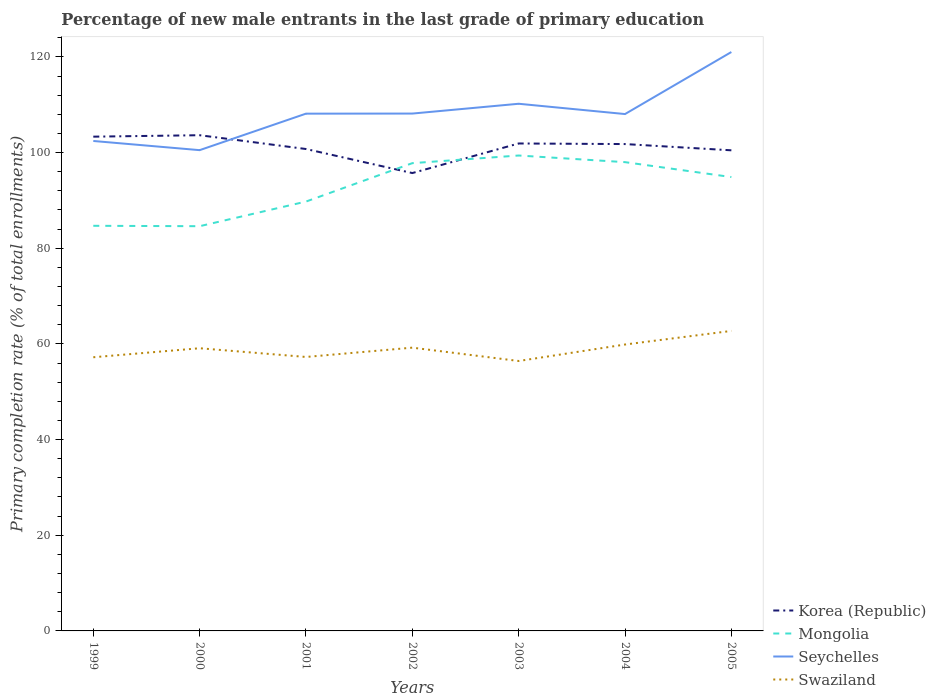How many different coloured lines are there?
Make the answer very short. 4. Across all years, what is the maximum percentage of new male entrants in Mongolia?
Your answer should be very brief. 84.61. What is the total percentage of new male entrants in Seychelles in the graph?
Give a very brief answer. -7.55. What is the difference between the highest and the second highest percentage of new male entrants in Seychelles?
Offer a very short reply. 20.51. How many years are there in the graph?
Ensure brevity in your answer.  7. What is the difference between two consecutive major ticks on the Y-axis?
Provide a succinct answer. 20. Where does the legend appear in the graph?
Keep it short and to the point. Bottom right. How many legend labels are there?
Make the answer very short. 4. What is the title of the graph?
Ensure brevity in your answer.  Percentage of new male entrants in the last grade of primary education. What is the label or title of the Y-axis?
Make the answer very short. Primary completion rate (% of total enrollments). What is the Primary completion rate (% of total enrollments) of Korea (Republic) in 1999?
Make the answer very short. 103.32. What is the Primary completion rate (% of total enrollments) of Mongolia in 1999?
Offer a very short reply. 84.69. What is the Primary completion rate (% of total enrollments) in Seychelles in 1999?
Offer a very short reply. 102.42. What is the Primary completion rate (% of total enrollments) in Swaziland in 1999?
Give a very brief answer. 57.21. What is the Primary completion rate (% of total enrollments) of Korea (Republic) in 2000?
Your answer should be compact. 103.63. What is the Primary completion rate (% of total enrollments) of Mongolia in 2000?
Ensure brevity in your answer.  84.61. What is the Primary completion rate (% of total enrollments) of Seychelles in 2000?
Give a very brief answer. 100.5. What is the Primary completion rate (% of total enrollments) in Swaziland in 2000?
Offer a very short reply. 59.09. What is the Primary completion rate (% of total enrollments) of Korea (Republic) in 2001?
Provide a short and direct response. 100.74. What is the Primary completion rate (% of total enrollments) of Mongolia in 2001?
Keep it short and to the point. 89.75. What is the Primary completion rate (% of total enrollments) of Seychelles in 2001?
Your response must be concise. 108.13. What is the Primary completion rate (% of total enrollments) in Swaziland in 2001?
Offer a terse response. 57.27. What is the Primary completion rate (% of total enrollments) in Korea (Republic) in 2002?
Provide a succinct answer. 95.71. What is the Primary completion rate (% of total enrollments) of Mongolia in 2002?
Keep it short and to the point. 97.78. What is the Primary completion rate (% of total enrollments) in Seychelles in 2002?
Your answer should be compact. 108.15. What is the Primary completion rate (% of total enrollments) of Swaziland in 2002?
Make the answer very short. 59.22. What is the Primary completion rate (% of total enrollments) in Korea (Republic) in 2003?
Give a very brief answer. 101.9. What is the Primary completion rate (% of total enrollments) in Mongolia in 2003?
Your response must be concise. 99.38. What is the Primary completion rate (% of total enrollments) of Seychelles in 2003?
Your response must be concise. 110.2. What is the Primary completion rate (% of total enrollments) in Swaziland in 2003?
Ensure brevity in your answer.  56.43. What is the Primary completion rate (% of total enrollments) in Korea (Republic) in 2004?
Make the answer very short. 101.77. What is the Primary completion rate (% of total enrollments) of Mongolia in 2004?
Provide a short and direct response. 98. What is the Primary completion rate (% of total enrollments) in Seychelles in 2004?
Provide a short and direct response. 108.05. What is the Primary completion rate (% of total enrollments) of Swaziland in 2004?
Ensure brevity in your answer.  59.87. What is the Primary completion rate (% of total enrollments) in Korea (Republic) in 2005?
Your response must be concise. 100.47. What is the Primary completion rate (% of total enrollments) in Mongolia in 2005?
Your response must be concise. 94.88. What is the Primary completion rate (% of total enrollments) in Seychelles in 2005?
Your answer should be compact. 121.02. What is the Primary completion rate (% of total enrollments) in Swaziland in 2005?
Your response must be concise. 62.72. Across all years, what is the maximum Primary completion rate (% of total enrollments) of Korea (Republic)?
Give a very brief answer. 103.63. Across all years, what is the maximum Primary completion rate (% of total enrollments) of Mongolia?
Your answer should be very brief. 99.38. Across all years, what is the maximum Primary completion rate (% of total enrollments) in Seychelles?
Give a very brief answer. 121.02. Across all years, what is the maximum Primary completion rate (% of total enrollments) in Swaziland?
Give a very brief answer. 62.72. Across all years, what is the minimum Primary completion rate (% of total enrollments) in Korea (Republic)?
Keep it short and to the point. 95.71. Across all years, what is the minimum Primary completion rate (% of total enrollments) in Mongolia?
Offer a terse response. 84.61. Across all years, what is the minimum Primary completion rate (% of total enrollments) in Seychelles?
Your answer should be very brief. 100.5. Across all years, what is the minimum Primary completion rate (% of total enrollments) in Swaziland?
Your answer should be compact. 56.43. What is the total Primary completion rate (% of total enrollments) of Korea (Republic) in the graph?
Your answer should be compact. 707.54. What is the total Primary completion rate (% of total enrollments) of Mongolia in the graph?
Your response must be concise. 649.09. What is the total Primary completion rate (% of total enrollments) of Seychelles in the graph?
Provide a succinct answer. 758.47. What is the total Primary completion rate (% of total enrollments) in Swaziland in the graph?
Provide a succinct answer. 411.8. What is the difference between the Primary completion rate (% of total enrollments) in Korea (Republic) in 1999 and that in 2000?
Offer a terse response. -0.3. What is the difference between the Primary completion rate (% of total enrollments) in Mongolia in 1999 and that in 2000?
Offer a terse response. 0.08. What is the difference between the Primary completion rate (% of total enrollments) of Seychelles in 1999 and that in 2000?
Your response must be concise. 1.92. What is the difference between the Primary completion rate (% of total enrollments) in Swaziland in 1999 and that in 2000?
Provide a short and direct response. -1.88. What is the difference between the Primary completion rate (% of total enrollments) of Korea (Republic) in 1999 and that in 2001?
Offer a terse response. 2.58. What is the difference between the Primary completion rate (% of total enrollments) of Mongolia in 1999 and that in 2001?
Your response must be concise. -5.07. What is the difference between the Primary completion rate (% of total enrollments) in Seychelles in 1999 and that in 2001?
Give a very brief answer. -5.71. What is the difference between the Primary completion rate (% of total enrollments) of Swaziland in 1999 and that in 2001?
Ensure brevity in your answer.  -0.06. What is the difference between the Primary completion rate (% of total enrollments) in Korea (Republic) in 1999 and that in 2002?
Offer a very short reply. 7.61. What is the difference between the Primary completion rate (% of total enrollments) in Mongolia in 1999 and that in 2002?
Offer a terse response. -13.1. What is the difference between the Primary completion rate (% of total enrollments) of Seychelles in 1999 and that in 2002?
Your answer should be very brief. -5.73. What is the difference between the Primary completion rate (% of total enrollments) of Swaziland in 1999 and that in 2002?
Ensure brevity in your answer.  -2.01. What is the difference between the Primary completion rate (% of total enrollments) in Korea (Republic) in 1999 and that in 2003?
Offer a very short reply. 1.42. What is the difference between the Primary completion rate (% of total enrollments) of Mongolia in 1999 and that in 2003?
Give a very brief answer. -14.69. What is the difference between the Primary completion rate (% of total enrollments) in Seychelles in 1999 and that in 2003?
Make the answer very short. -7.78. What is the difference between the Primary completion rate (% of total enrollments) in Swaziland in 1999 and that in 2003?
Offer a very short reply. 0.78. What is the difference between the Primary completion rate (% of total enrollments) in Korea (Republic) in 1999 and that in 2004?
Make the answer very short. 1.55. What is the difference between the Primary completion rate (% of total enrollments) in Mongolia in 1999 and that in 2004?
Keep it short and to the point. -13.31. What is the difference between the Primary completion rate (% of total enrollments) of Seychelles in 1999 and that in 2004?
Your answer should be compact. -5.63. What is the difference between the Primary completion rate (% of total enrollments) in Swaziland in 1999 and that in 2004?
Give a very brief answer. -2.66. What is the difference between the Primary completion rate (% of total enrollments) in Korea (Republic) in 1999 and that in 2005?
Your answer should be compact. 2.86. What is the difference between the Primary completion rate (% of total enrollments) of Mongolia in 1999 and that in 2005?
Provide a succinct answer. -10.19. What is the difference between the Primary completion rate (% of total enrollments) of Seychelles in 1999 and that in 2005?
Provide a succinct answer. -18.6. What is the difference between the Primary completion rate (% of total enrollments) in Swaziland in 1999 and that in 2005?
Give a very brief answer. -5.5. What is the difference between the Primary completion rate (% of total enrollments) of Korea (Republic) in 2000 and that in 2001?
Offer a very short reply. 2.89. What is the difference between the Primary completion rate (% of total enrollments) of Mongolia in 2000 and that in 2001?
Ensure brevity in your answer.  -5.15. What is the difference between the Primary completion rate (% of total enrollments) of Seychelles in 2000 and that in 2001?
Provide a short and direct response. -7.63. What is the difference between the Primary completion rate (% of total enrollments) in Swaziland in 2000 and that in 2001?
Your answer should be compact. 1.82. What is the difference between the Primary completion rate (% of total enrollments) of Korea (Republic) in 2000 and that in 2002?
Keep it short and to the point. 7.91. What is the difference between the Primary completion rate (% of total enrollments) in Mongolia in 2000 and that in 2002?
Offer a very short reply. -13.18. What is the difference between the Primary completion rate (% of total enrollments) in Seychelles in 2000 and that in 2002?
Provide a succinct answer. -7.65. What is the difference between the Primary completion rate (% of total enrollments) in Swaziland in 2000 and that in 2002?
Your answer should be very brief. -0.12. What is the difference between the Primary completion rate (% of total enrollments) of Korea (Republic) in 2000 and that in 2003?
Provide a short and direct response. 1.73. What is the difference between the Primary completion rate (% of total enrollments) of Mongolia in 2000 and that in 2003?
Ensure brevity in your answer.  -14.78. What is the difference between the Primary completion rate (% of total enrollments) of Seychelles in 2000 and that in 2003?
Provide a short and direct response. -9.7. What is the difference between the Primary completion rate (% of total enrollments) in Swaziland in 2000 and that in 2003?
Your response must be concise. 2.67. What is the difference between the Primary completion rate (% of total enrollments) in Korea (Republic) in 2000 and that in 2004?
Ensure brevity in your answer.  1.85. What is the difference between the Primary completion rate (% of total enrollments) of Mongolia in 2000 and that in 2004?
Provide a short and direct response. -13.39. What is the difference between the Primary completion rate (% of total enrollments) of Seychelles in 2000 and that in 2004?
Make the answer very short. -7.55. What is the difference between the Primary completion rate (% of total enrollments) in Swaziland in 2000 and that in 2004?
Provide a short and direct response. -0.78. What is the difference between the Primary completion rate (% of total enrollments) in Korea (Republic) in 2000 and that in 2005?
Give a very brief answer. 3.16. What is the difference between the Primary completion rate (% of total enrollments) in Mongolia in 2000 and that in 2005?
Offer a very short reply. -10.27. What is the difference between the Primary completion rate (% of total enrollments) of Seychelles in 2000 and that in 2005?
Your answer should be compact. -20.51. What is the difference between the Primary completion rate (% of total enrollments) in Swaziland in 2000 and that in 2005?
Give a very brief answer. -3.62. What is the difference between the Primary completion rate (% of total enrollments) in Korea (Republic) in 2001 and that in 2002?
Provide a succinct answer. 5.03. What is the difference between the Primary completion rate (% of total enrollments) in Mongolia in 2001 and that in 2002?
Give a very brief answer. -8.03. What is the difference between the Primary completion rate (% of total enrollments) in Seychelles in 2001 and that in 2002?
Provide a succinct answer. -0.02. What is the difference between the Primary completion rate (% of total enrollments) in Swaziland in 2001 and that in 2002?
Make the answer very short. -1.95. What is the difference between the Primary completion rate (% of total enrollments) in Korea (Republic) in 2001 and that in 2003?
Your response must be concise. -1.16. What is the difference between the Primary completion rate (% of total enrollments) in Mongolia in 2001 and that in 2003?
Make the answer very short. -9.63. What is the difference between the Primary completion rate (% of total enrollments) in Seychelles in 2001 and that in 2003?
Keep it short and to the point. -2.07. What is the difference between the Primary completion rate (% of total enrollments) in Swaziland in 2001 and that in 2003?
Provide a succinct answer. 0.84. What is the difference between the Primary completion rate (% of total enrollments) of Korea (Republic) in 2001 and that in 2004?
Provide a succinct answer. -1.03. What is the difference between the Primary completion rate (% of total enrollments) in Mongolia in 2001 and that in 2004?
Your answer should be compact. -8.24. What is the difference between the Primary completion rate (% of total enrollments) of Seychelles in 2001 and that in 2004?
Offer a terse response. 0.08. What is the difference between the Primary completion rate (% of total enrollments) in Swaziland in 2001 and that in 2004?
Keep it short and to the point. -2.6. What is the difference between the Primary completion rate (% of total enrollments) of Korea (Republic) in 2001 and that in 2005?
Provide a short and direct response. 0.27. What is the difference between the Primary completion rate (% of total enrollments) of Mongolia in 2001 and that in 2005?
Offer a very short reply. -5.12. What is the difference between the Primary completion rate (% of total enrollments) in Seychelles in 2001 and that in 2005?
Offer a very short reply. -12.88. What is the difference between the Primary completion rate (% of total enrollments) in Swaziland in 2001 and that in 2005?
Keep it short and to the point. -5.45. What is the difference between the Primary completion rate (% of total enrollments) in Korea (Republic) in 2002 and that in 2003?
Provide a short and direct response. -6.18. What is the difference between the Primary completion rate (% of total enrollments) of Mongolia in 2002 and that in 2003?
Keep it short and to the point. -1.6. What is the difference between the Primary completion rate (% of total enrollments) in Seychelles in 2002 and that in 2003?
Your response must be concise. -2.05. What is the difference between the Primary completion rate (% of total enrollments) of Swaziland in 2002 and that in 2003?
Provide a short and direct response. 2.79. What is the difference between the Primary completion rate (% of total enrollments) of Korea (Republic) in 2002 and that in 2004?
Provide a short and direct response. -6.06. What is the difference between the Primary completion rate (% of total enrollments) of Mongolia in 2002 and that in 2004?
Your answer should be very brief. -0.21. What is the difference between the Primary completion rate (% of total enrollments) in Seychelles in 2002 and that in 2004?
Make the answer very short. 0.1. What is the difference between the Primary completion rate (% of total enrollments) of Swaziland in 2002 and that in 2004?
Give a very brief answer. -0.66. What is the difference between the Primary completion rate (% of total enrollments) in Korea (Republic) in 2002 and that in 2005?
Offer a very short reply. -4.75. What is the difference between the Primary completion rate (% of total enrollments) in Mongolia in 2002 and that in 2005?
Offer a very short reply. 2.91. What is the difference between the Primary completion rate (% of total enrollments) of Seychelles in 2002 and that in 2005?
Provide a succinct answer. -12.87. What is the difference between the Primary completion rate (% of total enrollments) of Swaziland in 2002 and that in 2005?
Offer a terse response. -3.5. What is the difference between the Primary completion rate (% of total enrollments) of Korea (Republic) in 2003 and that in 2004?
Offer a very short reply. 0.12. What is the difference between the Primary completion rate (% of total enrollments) of Mongolia in 2003 and that in 2004?
Make the answer very short. 1.39. What is the difference between the Primary completion rate (% of total enrollments) of Seychelles in 2003 and that in 2004?
Provide a succinct answer. 2.15. What is the difference between the Primary completion rate (% of total enrollments) in Swaziland in 2003 and that in 2004?
Your answer should be compact. -3.45. What is the difference between the Primary completion rate (% of total enrollments) of Korea (Republic) in 2003 and that in 2005?
Offer a very short reply. 1.43. What is the difference between the Primary completion rate (% of total enrollments) of Mongolia in 2003 and that in 2005?
Make the answer very short. 4.51. What is the difference between the Primary completion rate (% of total enrollments) in Seychelles in 2003 and that in 2005?
Your answer should be compact. -10.82. What is the difference between the Primary completion rate (% of total enrollments) of Swaziland in 2003 and that in 2005?
Offer a terse response. -6.29. What is the difference between the Primary completion rate (% of total enrollments) of Korea (Republic) in 2004 and that in 2005?
Keep it short and to the point. 1.31. What is the difference between the Primary completion rate (% of total enrollments) of Mongolia in 2004 and that in 2005?
Make the answer very short. 3.12. What is the difference between the Primary completion rate (% of total enrollments) in Seychelles in 2004 and that in 2005?
Your answer should be compact. -12.97. What is the difference between the Primary completion rate (% of total enrollments) in Swaziland in 2004 and that in 2005?
Provide a short and direct response. -2.84. What is the difference between the Primary completion rate (% of total enrollments) in Korea (Republic) in 1999 and the Primary completion rate (% of total enrollments) in Mongolia in 2000?
Offer a very short reply. 18.72. What is the difference between the Primary completion rate (% of total enrollments) in Korea (Republic) in 1999 and the Primary completion rate (% of total enrollments) in Seychelles in 2000?
Ensure brevity in your answer.  2.82. What is the difference between the Primary completion rate (% of total enrollments) of Korea (Republic) in 1999 and the Primary completion rate (% of total enrollments) of Swaziland in 2000?
Your response must be concise. 44.23. What is the difference between the Primary completion rate (% of total enrollments) of Mongolia in 1999 and the Primary completion rate (% of total enrollments) of Seychelles in 2000?
Ensure brevity in your answer.  -15.81. What is the difference between the Primary completion rate (% of total enrollments) in Mongolia in 1999 and the Primary completion rate (% of total enrollments) in Swaziland in 2000?
Provide a succinct answer. 25.6. What is the difference between the Primary completion rate (% of total enrollments) in Seychelles in 1999 and the Primary completion rate (% of total enrollments) in Swaziland in 2000?
Provide a short and direct response. 43.33. What is the difference between the Primary completion rate (% of total enrollments) in Korea (Republic) in 1999 and the Primary completion rate (% of total enrollments) in Mongolia in 2001?
Offer a very short reply. 13.57. What is the difference between the Primary completion rate (% of total enrollments) in Korea (Republic) in 1999 and the Primary completion rate (% of total enrollments) in Seychelles in 2001?
Provide a short and direct response. -4.81. What is the difference between the Primary completion rate (% of total enrollments) in Korea (Republic) in 1999 and the Primary completion rate (% of total enrollments) in Swaziland in 2001?
Make the answer very short. 46.05. What is the difference between the Primary completion rate (% of total enrollments) in Mongolia in 1999 and the Primary completion rate (% of total enrollments) in Seychelles in 2001?
Make the answer very short. -23.44. What is the difference between the Primary completion rate (% of total enrollments) in Mongolia in 1999 and the Primary completion rate (% of total enrollments) in Swaziland in 2001?
Your answer should be compact. 27.42. What is the difference between the Primary completion rate (% of total enrollments) in Seychelles in 1999 and the Primary completion rate (% of total enrollments) in Swaziland in 2001?
Provide a succinct answer. 45.15. What is the difference between the Primary completion rate (% of total enrollments) in Korea (Republic) in 1999 and the Primary completion rate (% of total enrollments) in Mongolia in 2002?
Make the answer very short. 5.54. What is the difference between the Primary completion rate (% of total enrollments) of Korea (Republic) in 1999 and the Primary completion rate (% of total enrollments) of Seychelles in 2002?
Provide a short and direct response. -4.83. What is the difference between the Primary completion rate (% of total enrollments) in Korea (Republic) in 1999 and the Primary completion rate (% of total enrollments) in Swaziland in 2002?
Your answer should be very brief. 44.11. What is the difference between the Primary completion rate (% of total enrollments) of Mongolia in 1999 and the Primary completion rate (% of total enrollments) of Seychelles in 2002?
Provide a short and direct response. -23.46. What is the difference between the Primary completion rate (% of total enrollments) of Mongolia in 1999 and the Primary completion rate (% of total enrollments) of Swaziland in 2002?
Make the answer very short. 25.47. What is the difference between the Primary completion rate (% of total enrollments) of Seychelles in 1999 and the Primary completion rate (% of total enrollments) of Swaziland in 2002?
Offer a very short reply. 43.2. What is the difference between the Primary completion rate (% of total enrollments) of Korea (Republic) in 1999 and the Primary completion rate (% of total enrollments) of Mongolia in 2003?
Offer a very short reply. 3.94. What is the difference between the Primary completion rate (% of total enrollments) in Korea (Republic) in 1999 and the Primary completion rate (% of total enrollments) in Seychelles in 2003?
Offer a terse response. -6.88. What is the difference between the Primary completion rate (% of total enrollments) of Korea (Republic) in 1999 and the Primary completion rate (% of total enrollments) of Swaziland in 2003?
Your answer should be very brief. 46.9. What is the difference between the Primary completion rate (% of total enrollments) of Mongolia in 1999 and the Primary completion rate (% of total enrollments) of Seychelles in 2003?
Offer a terse response. -25.51. What is the difference between the Primary completion rate (% of total enrollments) of Mongolia in 1999 and the Primary completion rate (% of total enrollments) of Swaziland in 2003?
Offer a very short reply. 28.26. What is the difference between the Primary completion rate (% of total enrollments) of Seychelles in 1999 and the Primary completion rate (% of total enrollments) of Swaziland in 2003?
Your answer should be very brief. 45.99. What is the difference between the Primary completion rate (% of total enrollments) of Korea (Republic) in 1999 and the Primary completion rate (% of total enrollments) of Mongolia in 2004?
Give a very brief answer. 5.33. What is the difference between the Primary completion rate (% of total enrollments) of Korea (Republic) in 1999 and the Primary completion rate (% of total enrollments) of Seychelles in 2004?
Your response must be concise. -4.73. What is the difference between the Primary completion rate (% of total enrollments) of Korea (Republic) in 1999 and the Primary completion rate (% of total enrollments) of Swaziland in 2004?
Ensure brevity in your answer.  43.45. What is the difference between the Primary completion rate (% of total enrollments) of Mongolia in 1999 and the Primary completion rate (% of total enrollments) of Seychelles in 2004?
Your answer should be compact. -23.36. What is the difference between the Primary completion rate (% of total enrollments) in Mongolia in 1999 and the Primary completion rate (% of total enrollments) in Swaziland in 2004?
Keep it short and to the point. 24.82. What is the difference between the Primary completion rate (% of total enrollments) in Seychelles in 1999 and the Primary completion rate (% of total enrollments) in Swaziland in 2004?
Ensure brevity in your answer.  42.55. What is the difference between the Primary completion rate (% of total enrollments) in Korea (Republic) in 1999 and the Primary completion rate (% of total enrollments) in Mongolia in 2005?
Offer a terse response. 8.45. What is the difference between the Primary completion rate (% of total enrollments) in Korea (Republic) in 1999 and the Primary completion rate (% of total enrollments) in Seychelles in 2005?
Provide a succinct answer. -17.69. What is the difference between the Primary completion rate (% of total enrollments) in Korea (Republic) in 1999 and the Primary completion rate (% of total enrollments) in Swaziland in 2005?
Your answer should be very brief. 40.61. What is the difference between the Primary completion rate (% of total enrollments) in Mongolia in 1999 and the Primary completion rate (% of total enrollments) in Seychelles in 2005?
Offer a terse response. -36.33. What is the difference between the Primary completion rate (% of total enrollments) of Mongolia in 1999 and the Primary completion rate (% of total enrollments) of Swaziland in 2005?
Make the answer very short. 21.97. What is the difference between the Primary completion rate (% of total enrollments) of Seychelles in 1999 and the Primary completion rate (% of total enrollments) of Swaziland in 2005?
Offer a terse response. 39.71. What is the difference between the Primary completion rate (% of total enrollments) of Korea (Republic) in 2000 and the Primary completion rate (% of total enrollments) of Mongolia in 2001?
Provide a succinct answer. 13.87. What is the difference between the Primary completion rate (% of total enrollments) in Korea (Republic) in 2000 and the Primary completion rate (% of total enrollments) in Seychelles in 2001?
Provide a succinct answer. -4.51. What is the difference between the Primary completion rate (% of total enrollments) of Korea (Republic) in 2000 and the Primary completion rate (% of total enrollments) of Swaziland in 2001?
Your answer should be very brief. 46.36. What is the difference between the Primary completion rate (% of total enrollments) in Mongolia in 2000 and the Primary completion rate (% of total enrollments) in Seychelles in 2001?
Make the answer very short. -23.53. What is the difference between the Primary completion rate (% of total enrollments) in Mongolia in 2000 and the Primary completion rate (% of total enrollments) in Swaziland in 2001?
Ensure brevity in your answer.  27.34. What is the difference between the Primary completion rate (% of total enrollments) of Seychelles in 2000 and the Primary completion rate (% of total enrollments) of Swaziland in 2001?
Provide a short and direct response. 43.23. What is the difference between the Primary completion rate (% of total enrollments) in Korea (Republic) in 2000 and the Primary completion rate (% of total enrollments) in Mongolia in 2002?
Offer a very short reply. 5.84. What is the difference between the Primary completion rate (% of total enrollments) of Korea (Republic) in 2000 and the Primary completion rate (% of total enrollments) of Seychelles in 2002?
Offer a terse response. -4.52. What is the difference between the Primary completion rate (% of total enrollments) in Korea (Republic) in 2000 and the Primary completion rate (% of total enrollments) in Swaziland in 2002?
Your answer should be compact. 44.41. What is the difference between the Primary completion rate (% of total enrollments) of Mongolia in 2000 and the Primary completion rate (% of total enrollments) of Seychelles in 2002?
Provide a short and direct response. -23.54. What is the difference between the Primary completion rate (% of total enrollments) in Mongolia in 2000 and the Primary completion rate (% of total enrollments) in Swaziland in 2002?
Give a very brief answer. 25.39. What is the difference between the Primary completion rate (% of total enrollments) in Seychelles in 2000 and the Primary completion rate (% of total enrollments) in Swaziland in 2002?
Offer a very short reply. 41.29. What is the difference between the Primary completion rate (% of total enrollments) in Korea (Republic) in 2000 and the Primary completion rate (% of total enrollments) in Mongolia in 2003?
Give a very brief answer. 4.24. What is the difference between the Primary completion rate (% of total enrollments) in Korea (Republic) in 2000 and the Primary completion rate (% of total enrollments) in Seychelles in 2003?
Offer a terse response. -6.57. What is the difference between the Primary completion rate (% of total enrollments) of Korea (Republic) in 2000 and the Primary completion rate (% of total enrollments) of Swaziland in 2003?
Make the answer very short. 47.2. What is the difference between the Primary completion rate (% of total enrollments) of Mongolia in 2000 and the Primary completion rate (% of total enrollments) of Seychelles in 2003?
Your response must be concise. -25.59. What is the difference between the Primary completion rate (% of total enrollments) of Mongolia in 2000 and the Primary completion rate (% of total enrollments) of Swaziland in 2003?
Keep it short and to the point. 28.18. What is the difference between the Primary completion rate (% of total enrollments) in Seychelles in 2000 and the Primary completion rate (% of total enrollments) in Swaziland in 2003?
Provide a succinct answer. 44.08. What is the difference between the Primary completion rate (% of total enrollments) in Korea (Republic) in 2000 and the Primary completion rate (% of total enrollments) in Mongolia in 2004?
Make the answer very short. 5.63. What is the difference between the Primary completion rate (% of total enrollments) of Korea (Republic) in 2000 and the Primary completion rate (% of total enrollments) of Seychelles in 2004?
Offer a very short reply. -4.42. What is the difference between the Primary completion rate (% of total enrollments) of Korea (Republic) in 2000 and the Primary completion rate (% of total enrollments) of Swaziland in 2004?
Ensure brevity in your answer.  43.75. What is the difference between the Primary completion rate (% of total enrollments) of Mongolia in 2000 and the Primary completion rate (% of total enrollments) of Seychelles in 2004?
Provide a short and direct response. -23.44. What is the difference between the Primary completion rate (% of total enrollments) in Mongolia in 2000 and the Primary completion rate (% of total enrollments) in Swaziland in 2004?
Make the answer very short. 24.73. What is the difference between the Primary completion rate (% of total enrollments) in Seychelles in 2000 and the Primary completion rate (% of total enrollments) in Swaziland in 2004?
Give a very brief answer. 40.63. What is the difference between the Primary completion rate (% of total enrollments) of Korea (Republic) in 2000 and the Primary completion rate (% of total enrollments) of Mongolia in 2005?
Make the answer very short. 8.75. What is the difference between the Primary completion rate (% of total enrollments) in Korea (Republic) in 2000 and the Primary completion rate (% of total enrollments) in Seychelles in 2005?
Give a very brief answer. -17.39. What is the difference between the Primary completion rate (% of total enrollments) of Korea (Republic) in 2000 and the Primary completion rate (% of total enrollments) of Swaziland in 2005?
Keep it short and to the point. 40.91. What is the difference between the Primary completion rate (% of total enrollments) of Mongolia in 2000 and the Primary completion rate (% of total enrollments) of Seychelles in 2005?
Offer a very short reply. -36.41. What is the difference between the Primary completion rate (% of total enrollments) of Mongolia in 2000 and the Primary completion rate (% of total enrollments) of Swaziland in 2005?
Your answer should be compact. 21.89. What is the difference between the Primary completion rate (% of total enrollments) in Seychelles in 2000 and the Primary completion rate (% of total enrollments) in Swaziland in 2005?
Provide a succinct answer. 37.79. What is the difference between the Primary completion rate (% of total enrollments) in Korea (Republic) in 2001 and the Primary completion rate (% of total enrollments) in Mongolia in 2002?
Provide a succinct answer. 2.96. What is the difference between the Primary completion rate (% of total enrollments) in Korea (Republic) in 2001 and the Primary completion rate (% of total enrollments) in Seychelles in 2002?
Keep it short and to the point. -7.41. What is the difference between the Primary completion rate (% of total enrollments) in Korea (Republic) in 2001 and the Primary completion rate (% of total enrollments) in Swaziland in 2002?
Your response must be concise. 41.52. What is the difference between the Primary completion rate (% of total enrollments) in Mongolia in 2001 and the Primary completion rate (% of total enrollments) in Seychelles in 2002?
Offer a very short reply. -18.4. What is the difference between the Primary completion rate (% of total enrollments) in Mongolia in 2001 and the Primary completion rate (% of total enrollments) in Swaziland in 2002?
Give a very brief answer. 30.54. What is the difference between the Primary completion rate (% of total enrollments) in Seychelles in 2001 and the Primary completion rate (% of total enrollments) in Swaziland in 2002?
Your response must be concise. 48.92. What is the difference between the Primary completion rate (% of total enrollments) of Korea (Republic) in 2001 and the Primary completion rate (% of total enrollments) of Mongolia in 2003?
Ensure brevity in your answer.  1.36. What is the difference between the Primary completion rate (% of total enrollments) of Korea (Republic) in 2001 and the Primary completion rate (% of total enrollments) of Seychelles in 2003?
Your answer should be compact. -9.46. What is the difference between the Primary completion rate (% of total enrollments) of Korea (Republic) in 2001 and the Primary completion rate (% of total enrollments) of Swaziland in 2003?
Keep it short and to the point. 44.31. What is the difference between the Primary completion rate (% of total enrollments) of Mongolia in 2001 and the Primary completion rate (% of total enrollments) of Seychelles in 2003?
Offer a terse response. -20.44. What is the difference between the Primary completion rate (% of total enrollments) of Mongolia in 2001 and the Primary completion rate (% of total enrollments) of Swaziland in 2003?
Keep it short and to the point. 33.33. What is the difference between the Primary completion rate (% of total enrollments) in Seychelles in 2001 and the Primary completion rate (% of total enrollments) in Swaziland in 2003?
Ensure brevity in your answer.  51.71. What is the difference between the Primary completion rate (% of total enrollments) of Korea (Republic) in 2001 and the Primary completion rate (% of total enrollments) of Mongolia in 2004?
Offer a terse response. 2.74. What is the difference between the Primary completion rate (% of total enrollments) of Korea (Republic) in 2001 and the Primary completion rate (% of total enrollments) of Seychelles in 2004?
Your answer should be very brief. -7.31. What is the difference between the Primary completion rate (% of total enrollments) of Korea (Republic) in 2001 and the Primary completion rate (% of total enrollments) of Swaziland in 2004?
Ensure brevity in your answer.  40.87. What is the difference between the Primary completion rate (% of total enrollments) of Mongolia in 2001 and the Primary completion rate (% of total enrollments) of Seychelles in 2004?
Provide a short and direct response. -18.3. What is the difference between the Primary completion rate (% of total enrollments) in Mongolia in 2001 and the Primary completion rate (% of total enrollments) in Swaziland in 2004?
Your answer should be compact. 29.88. What is the difference between the Primary completion rate (% of total enrollments) in Seychelles in 2001 and the Primary completion rate (% of total enrollments) in Swaziland in 2004?
Offer a very short reply. 48.26. What is the difference between the Primary completion rate (% of total enrollments) in Korea (Republic) in 2001 and the Primary completion rate (% of total enrollments) in Mongolia in 2005?
Your answer should be very brief. 5.86. What is the difference between the Primary completion rate (% of total enrollments) of Korea (Republic) in 2001 and the Primary completion rate (% of total enrollments) of Seychelles in 2005?
Offer a terse response. -20.28. What is the difference between the Primary completion rate (% of total enrollments) of Korea (Republic) in 2001 and the Primary completion rate (% of total enrollments) of Swaziland in 2005?
Your answer should be compact. 38.02. What is the difference between the Primary completion rate (% of total enrollments) in Mongolia in 2001 and the Primary completion rate (% of total enrollments) in Seychelles in 2005?
Make the answer very short. -31.26. What is the difference between the Primary completion rate (% of total enrollments) in Mongolia in 2001 and the Primary completion rate (% of total enrollments) in Swaziland in 2005?
Keep it short and to the point. 27.04. What is the difference between the Primary completion rate (% of total enrollments) of Seychelles in 2001 and the Primary completion rate (% of total enrollments) of Swaziland in 2005?
Provide a short and direct response. 45.42. What is the difference between the Primary completion rate (% of total enrollments) of Korea (Republic) in 2002 and the Primary completion rate (% of total enrollments) of Mongolia in 2003?
Ensure brevity in your answer.  -3.67. What is the difference between the Primary completion rate (% of total enrollments) of Korea (Republic) in 2002 and the Primary completion rate (% of total enrollments) of Seychelles in 2003?
Your response must be concise. -14.48. What is the difference between the Primary completion rate (% of total enrollments) of Korea (Republic) in 2002 and the Primary completion rate (% of total enrollments) of Swaziland in 2003?
Give a very brief answer. 39.29. What is the difference between the Primary completion rate (% of total enrollments) of Mongolia in 2002 and the Primary completion rate (% of total enrollments) of Seychelles in 2003?
Keep it short and to the point. -12.41. What is the difference between the Primary completion rate (% of total enrollments) in Mongolia in 2002 and the Primary completion rate (% of total enrollments) in Swaziland in 2003?
Offer a terse response. 41.36. What is the difference between the Primary completion rate (% of total enrollments) of Seychelles in 2002 and the Primary completion rate (% of total enrollments) of Swaziland in 2003?
Your answer should be compact. 51.72. What is the difference between the Primary completion rate (% of total enrollments) of Korea (Republic) in 2002 and the Primary completion rate (% of total enrollments) of Mongolia in 2004?
Provide a short and direct response. -2.28. What is the difference between the Primary completion rate (% of total enrollments) in Korea (Republic) in 2002 and the Primary completion rate (% of total enrollments) in Seychelles in 2004?
Your answer should be very brief. -12.34. What is the difference between the Primary completion rate (% of total enrollments) in Korea (Republic) in 2002 and the Primary completion rate (% of total enrollments) in Swaziland in 2004?
Provide a succinct answer. 35.84. What is the difference between the Primary completion rate (% of total enrollments) of Mongolia in 2002 and the Primary completion rate (% of total enrollments) of Seychelles in 2004?
Your answer should be very brief. -10.26. What is the difference between the Primary completion rate (% of total enrollments) in Mongolia in 2002 and the Primary completion rate (% of total enrollments) in Swaziland in 2004?
Provide a short and direct response. 37.91. What is the difference between the Primary completion rate (% of total enrollments) of Seychelles in 2002 and the Primary completion rate (% of total enrollments) of Swaziland in 2004?
Offer a very short reply. 48.28. What is the difference between the Primary completion rate (% of total enrollments) of Korea (Republic) in 2002 and the Primary completion rate (% of total enrollments) of Mongolia in 2005?
Your answer should be compact. 0.84. What is the difference between the Primary completion rate (% of total enrollments) of Korea (Republic) in 2002 and the Primary completion rate (% of total enrollments) of Seychelles in 2005?
Your answer should be compact. -25.3. What is the difference between the Primary completion rate (% of total enrollments) in Korea (Republic) in 2002 and the Primary completion rate (% of total enrollments) in Swaziland in 2005?
Provide a short and direct response. 33. What is the difference between the Primary completion rate (% of total enrollments) in Mongolia in 2002 and the Primary completion rate (% of total enrollments) in Seychelles in 2005?
Make the answer very short. -23.23. What is the difference between the Primary completion rate (% of total enrollments) in Mongolia in 2002 and the Primary completion rate (% of total enrollments) in Swaziland in 2005?
Your response must be concise. 35.07. What is the difference between the Primary completion rate (% of total enrollments) of Seychelles in 2002 and the Primary completion rate (% of total enrollments) of Swaziland in 2005?
Make the answer very short. 45.43. What is the difference between the Primary completion rate (% of total enrollments) in Korea (Republic) in 2003 and the Primary completion rate (% of total enrollments) in Mongolia in 2004?
Your answer should be very brief. 3.9. What is the difference between the Primary completion rate (% of total enrollments) in Korea (Republic) in 2003 and the Primary completion rate (% of total enrollments) in Seychelles in 2004?
Your answer should be compact. -6.15. What is the difference between the Primary completion rate (% of total enrollments) of Korea (Republic) in 2003 and the Primary completion rate (% of total enrollments) of Swaziland in 2004?
Your response must be concise. 42.03. What is the difference between the Primary completion rate (% of total enrollments) in Mongolia in 2003 and the Primary completion rate (% of total enrollments) in Seychelles in 2004?
Ensure brevity in your answer.  -8.67. What is the difference between the Primary completion rate (% of total enrollments) of Mongolia in 2003 and the Primary completion rate (% of total enrollments) of Swaziland in 2004?
Your answer should be compact. 39.51. What is the difference between the Primary completion rate (% of total enrollments) of Seychelles in 2003 and the Primary completion rate (% of total enrollments) of Swaziland in 2004?
Ensure brevity in your answer.  50.33. What is the difference between the Primary completion rate (% of total enrollments) in Korea (Republic) in 2003 and the Primary completion rate (% of total enrollments) in Mongolia in 2005?
Keep it short and to the point. 7.02. What is the difference between the Primary completion rate (% of total enrollments) of Korea (Republic) in 2003 and the Primary completion rate (% of total enrollments) of Seychelles in 2005?
Offer a very short reply. -19.12. What is the difference between the Primary completion rate (% of total enrollments) in Korea (Republic) in 2003 and the Primary completion rate (% of total enrollments) in Swaziland in 2005?
Provide a short and direct response. 39.18. What is the difference between the Primary completion rate (% of total enrollments) in Mongolia in 2003 and the Primary completion rate (% of total enrollments) in Seychelles in 2005?
Your answer should be compact. -21.63. What is the difference between the Primary completion rate (% of total enrollments) of Mongolia in 2003 and the Primary completion rate (% of total enrollments) of Swaziland in 2005?
Provide a succinct answer. 36.67. What is the difference between the Primary completion rate (% of total enrollments) of Seychelles in 2003 and the Primary completion rate (% of total enrollments) of Swaziland in 2005?
Ensure brevity in your answer.  47.48. What is the difference between the Primary completion rate (% of total enrollments) in Korea (Republic) in 2004 and the Primary completion rate (% of total enrollments) in Mongolia in 2005?
Provide a succinct answer. 6.9. What is the difference between the Primary completion rate (% of total enrollments) of Korea (Republic) in 2004 and the Primary completion rate (% of total enrollments) of Seychelles in 2005?
Provide a succinct answer. -19.24. What is the difference between the Primary completion rate (% of total enrollments) of Korea (Republic) in 2004 and the Primary completion rate (% of total enrollments) of Swaziland in 2005?
Your response must be concise. 39.06. What is the difference between the Primary completion rate (% of total enrollments) in Mongolia in 2004 and the Primary completion rate (% of total enrollments) in Seychelles in 2005?
Offer a very short reply. -23.02. What is the difference between the Primary completion rate (% of total enrollments) of Mongolia in 2004 and the Primary completion rate (% of total enrollments) of Swaziland in 2005?
Your answer should be very brief. 35.28. What is the difference between the Primary completion rate (% of total enrollments) of Seychelles in 2004 and the Primary completion rate (% of total enrollments) of Swaziland in 2005?
Your answer should be compact. 45.33. What is the average Primary completion rate (% of total enrollments) in Korea (Republic) per year?
Ensure brevity in your answer.  101.08. What is the average Primary completion rate (% of total enrollments) in Mongolia per year?
Make the answer very short. 92.73. What is the average Primary completion rate (% of total enrollments) in Seychelles per year?
Provide a succinct answer. 108.35. What is the average Primary completion rate (% of total enrollments) of Swaziland per year?
Your answer should be very brief. 58.83. In the year 1999, what is the difference between the Primary completion rate (% of total enrollments) of Korea (Republic) and Primary completion rate (% of total enrollments) of Mongolia?
Make the answer very short. 18.63. In the year 1999, what is the difference between the Primary completion rate (% of total enrollments) of Korea (Republic) and Primary completion rate (% of total enrollments) of Seychelles?
Give a very brief answer. 0.9. In the year 1999, what is the difference between the Primary completion rate (% of total enrollments) of Korea (Republic) and Primary completion rate (% of total enrollments) of Swaziland?
Offer a terse response. 46.11. In the year 1999, what is the difference between the Primary completion rate (% of total enrollments) in Mongolia and Primary completion rate (% of total enrollments) in Seychelles?
Offer a terse response. -17.73. In the year 1999, what is the difference between the Primary completion rate (% of total enrollments) in Mongolia and Primary completion rate (% of total enrollments) in Swaziland?
Provide a short and direct response. 27.48. In the year 1999, what is the difference between the Primary completion rate (% of total enrollments) in Seychelles and Primary completion rate (% of total enrollments) in Swaziland?
Keep it short and to the point. 45.21. In the year 2000, what is the difference between the Primary completion rate (% of total enrollments) of Korea (Republic) and Primary completion rate (% of total enrollments) of Mongolia?
Offer a terse response. 19.02. In the year 2000, what is the difference between the Primary completion rate (% of total enrollments) of Korea (Republic) and Primary completion rate (% of total enrollments) of Seychelles?
Ensure brevity in your answer.  3.12. In the year 2000, what is the difference between the Primary completion rate (% of total enrollments) in Korea (Republic) and Primary completion rate (% of total enrollments) in Swaziland?
Offer a terse response. 44.53. In the year 2000, what is the difference between the Primary completion rate (% of total enrollments) of Mongolia and Primary completion rate (% of total enrollments) of Seychelles?
Provide a succinct answer. -15.9. In the year 2000, what is the difference between the Primary completion rate (% of total enrollments) in Mongolia and Primary completion rate (% of total enrollments) in Swaziland?
Keep it short and to the point. 25.51. In the year 2000, what is the difference between the Primary completion rate (% of total enrollments) of Seychelles and Primary completion rate (% of total enrollments) of Swaziland?
Your answer should be compact. 41.41. In the year 2001, what is the difference between the Primary completion rate (% of total enrollments) of Korea (Republic) and Primary completion rate (% of total enrollments) of Mongolia?
Ensure brevity in your answer.  10.99. In the year 2001, what is the difference between the Primary completion rate (% of total enrollments) of Korea (Republic) and Primary completion rate (% of total enrollments) of Seychelles?
Ensure brevity in your answer.  -7.39. In the year 2001, what is the difference between the Primary completion rate (% of total enrollments) in Korea (Republic) and Primary completion rate (% of total enrollments) in Swaziland?
Make the answer very short. 43.47. In the year 2001, what is the difference between the Primary completion rate (% of total enrollments) of Mongolia and Primary completion rate (% of total enrollments) of Seychelles?
Provide a succinct answer. -18.38. In the year 2001, what is the difference between the Primary completion rate (% of total enrollments) in Mongolia and Primary completion rate (% of total enrollments) in Swaziland?
Offer a very short reply. 32.48. In the year 2001, what is the difference between the Primary completion rate (% of total enrollments) in Seychelles and Primary completion rate (% of total enrollments) in Swaziland?
Provide a succinct answer. 50.86. In the year 2002, what is the difference between the Primary completion rate (% of total enrollments) in Korea (Republic) and Primary completion rate (% of total enrollments) in Mongolia?
Your response must be concise. -2.07. In the year 2002, what is the difference between the Primary completion rate (% of total enrollments) in Korea (Republic) and Primary completion rate (% of total enrollments) in Seychelles?
Keep it short and to the point. -12.44. In the year 2002, what is the difference between the Primary completion rate (% of total enrollments) of Korea (Republic) and Primary completion rate (% of total enrollments) of Swaziland?
Your answer should be very brief. 36.5. In the year 2002, what is the difference between the Primary completion rate (% of total enrollments) in Mongolia and Primary completion rate (% of total enrollments) in Seychelles?
Provide a short and direct response. -10.37. In the year 2002, what is the difference between the Primary completion rate (% of total enrollments) of Mongolia and Primary completion rate (% of total enrollments) of Swaziland?
Give a very brief answer. 38.57. In the year 2002, what is the difference between the Primary completion rate (% of total enrollments) of Seychelles and Primary completion rate (% of total enrollments) of Swaziland?
Your response must be concise. 48.93. In the year 2003, what is the difference between the Primary completion rate (% of total enrollments) of Korea (Republic) and Primary completion rate (% of total enrollments) of Mongolia?
Offer a terse response. 2.52. In the year 2003, what is the difference between the Primary completion rate (% of total enrollments) of Korea (Republic) and Primary completion rate (% of total enrollments) of Seychelles?
Your answer should be very brief. -8.3. In the year 2003, what is the difference between the Primary completion rate (% of total enrollments) of Korea (Republic) and Primary completion rate (% of total enrollments) of Swaziland?
Offer a very short reply. 45.47. In the year 2003, what is the difference between the Primary completion rate (% of total enrollments) in Mongolia and Primary completion rate (% of total enrollments) in Seychelles?
Your answer should be compact. -10.82. In the year 2003, what is the difference between the Primary completion rate (% of total enrollments) in Mongolia and Primary completion rate (% of total enrollments) in Swaziland?
Your response must be concise. 42.96. In the year 2003, what is the difference between the Primary completion rate (% of total enrollments) of Seychelles and Primary completion rate (% of total enrollments) of Swaziland?
Give a very brief answer. 53.77. In the year 2004, what is the difference between the Primary completion rate (% of total enrollments) of Korea (Republic) and Primary completion rate (% of total enrollments) of Mongolia?
Your response must be concise. 3.78. In the year 2004, what is the difference between the Primary completion rate (% of total enrollments) in Korea (Republic) and Primary completion rate (% of total enrollments) in Seychelles?
Your answer should be compact. -6.27. In the year 2004, what is the difference between the Primary completion rate (% of total enrollments) of Korea (Republic) and Primary completion rate (% of total enrollments) of Swaziland?
Your answer should be compact. 41.9. In the year 2004, what is the difference between the Primary completion rate (% of total enrollments) in Mongolia and Primary completion rate (% of total enrollments) in Seychelles?
Make the answer very short. -10.05. In the year 2004, what is the difference between the Primary completion rate (% of total enrollments) of Mongolia and Primary completion rate (% of total enrollments) of Swaziland?
Keep it short and to the point. 38.12. In the year 2004, what is the difference between the Primary completion rate (% of total enrollments) of Seychelles and Primary completion rate (% of total enrollments) of Swaziland?
Offer a terse response. 48.18. In the year 2005, what is the difference between the Primary completion rate (% of total enrollments) of Korea (Republic) and Primary completion rate (% of total enrollments) of Mongolia?
Your answer should be very brief. 5.59. In the year 2005, what is the difference between the Primary completion rate (% of total enrollments) in Korea (Republic) and Primary completion rate (% of total enrollments) in Seychelles?
Ensure brevity in your answer.  -20.55. In the year 2005, what is the difference between the Primary completion rate (% of total enrollments) in Korea (Republic) and Primary completion rate (% of total enrollments) in Swaziland?
Your answer should be very brief. 37.75. In the year 2005, what is the difference between the Primary completion rate (% of total enrollments) of Mongolia and Primary completion rate (% of total enrollments) of Seychelles?
Ensure brevity in your answer.  -26.14. In the year 2005, what is the difference between the Primary completion rate (% of total enrollments) in Mongolia and Primary completion rate (% of total enrollments) in Swaziland?
Make the answer very short. 32.16. In the year 2005, what is the difference between the Primary completion rate (% of total enrollments) in Seychelles and Primary completion rate (% of total enrollments) in Swaziland?
Your answer should be very brief. 58.3. What is the ratio of the Primary completion rate (% of total enrollments) of Seychelles in 1999 to that in 2000?
Your answer should be compact. 1.02. What is the ratio of the Primary completion rate (% of total enrollments) in Swaziland in 1999 to that in 2000?
Keep it short and to the point. 0.97. What is the ratio of the Primary completion rate (% of total enrollments) in Korea (Republic) in 1999 to that in 2001?
Your answer should be compact. 1.03. What is the ratio of the Primary completion rate (% of total enrollments) of Mongolia in 1999 to that in 2001?
Ensure brevity in your answer.  0.94. What is the ratio of the Primary completion rate (% of total enrollments) in Seychelles in 1999 to that in 2001?
Ensure brevity in your answer.  0.95. What is the ratio of the Primary completion rate (% of total enrollments) of Swaziland in 1999 to that in 2001?
Your response must be concise. 1. What is the ratio of the Primary completion rate (% of total enrollments) of Korea (Republic) in 1999 to that in 2002?
Provide a short and direct response. 1.08. What is the ratio of the Primary completion rate (% of total enrollments) in Mongolia in 1999 to that in 2002?
Make the answer very short. 0.87. What is the ratio of the Primary completion rate (% of total enrollments) in Seychelles in 1999 to that in 2002?
Make the answer very short. 0.95. What is the ratio of the Primary completion rate (% of total enrollments) in Swaziland in 1999 to that in 2002?
Provide a succinct answer. 0.97. What is the ratio of the Primary completion rate (% of total enrollments) of Mongolia in 1999 to that in 2003?
Offer a very short reply. 0.85. What is the ratio of the Primary completion rate (% of total enrollments) of Seychelles in 1999 to that in 2003?
Your answer should be compact. 0.93. What is the ratio of the Primary completion rate (% of total enrollments) in Swaziland in 1999 to that in 2003?
Ensure brevity in your answer.  1.01. What is the ratio of the Primary completion rate (% of total enrollments) in Korea (Republic) in 1999 to that in 2004?
Provide a succinct answer. 1.02. What is the ratio of the Primary completion rate (% of total enrollments) in Mongolia in 1999 to that in 2004?
Provide a succinct answer. 0.86. What is the ratio of the Primary completion rate (% of total enrollments) of Seychelles in 1999 to that in 2004?
Your response must be concise. 0.95. What is the ratio of the Primary completion rate (% of total enrollments) of Swaziland in 1999 to that in 2004?
Provide a succinct answer. 0.96. What is the ratio of the Primary completion rate (% of total enrollments) of Korea (Republic) in 1999 to that in 2005?
Your answer should be compact. 1.03. What is the ratio of the Primary completion rate (% of total enrollments) in Mongolia in 1999 to that in 2005?
Provide a short and direct response. 0.89. What is the ratio of the Primary completion rate (% of total enrollments) in Seychelles in 1999 to that in 2005?
Keep it short and to the point. 0.85. What is the ratio of the Primary completion rate (% of total enrollments) in Swaziland in 1999 to that in 2005?
Offer a terse response. 0.91. What is the ratio of the Primary completion rate (% of total enrollments) in Korea (Republic) in 2000 to that in 2001?
Your answer should be compact. 1.03. What is the ratio of the Primary completion rate (% of total enrollments) in Mongolia in 2000 to that in 2001?
Offer a very short reply. 0.94. What is the ratio of the Primary completion rate (% of total enrollments) in Seychelles in 2000 to that in 2001?
Keep it short and to the point. 0.93. What is the ratio of the Primary completion rate (% of total enrollments) of Swaziland in 2000 to that in 2001?
Give a very brief answer. 1.03. What is the ratio of the Primary completion rate (% of total enrollments) of Korea (Republic) in 2000 to that in 2002?
Offer a very short reply. 1.08. What is the ratio of the Primary completion rate (% of total enrollments) of Mongolia in 2000 to that in 2002?
Offer a terse response. 0.87. What is the ratio of the Primary completion rate (% of total enrollments) in Seychelles in 2000 to that in 2002?
Make the answer very short. 0.93. What is the ratio of the Primary completion rate (% of total enrollments) of Korea (Republic) in 2000 to that in 2003?
Your answer should be compact. 1.02. What is the ratio of the Primary completion rate (% of total enrollments) in Mongolia in 2000 to that in 2003?
Offer a terse response. 0.85. What is the ratio of the Primary completion rate (% of total enrollments) in Seychelles in 2000 to that in 2003?
Provide a succinct answer. 0.91. What is the ratio of the Primary completion rate (% of total enrollments) in Swaziland in 2000 to that in 2003?
Your answer should be very brief. 1.05. What is the ratio of the Primary completion rate (% of total enrollments) of Korea (Republic) in 2000 to that in 2004?
Your answer should be compact. 1.02. What is the ratio of the Primary completion rate (% of total enrollments) in Mongolia in 2000 to that in 2004?
Your answer should be very brief. 0.86. What is the ratio of the Primary completion rate (% of total enrollments) in Seychelles in 2000 to that in 2004?
Offer a very short reply. 0.93. What is the ratio of the Primary completion rate (% of total enrollments) in Swaziland in 2000 to that in 2004?
Ensure brevity in your answer.  0.99. What is the ratio of the Primary completion rate (% of total enrollments) of Korea (Republic) in 2000 to that in 2005?
Provide a succinct answer. 1.03. What is the ratio of the Primary completion rate (% of total enrollments) of Mongolia in 2000 to that in 2005?
Provide a succinct answer. 0.89. What is the ratio of the Primary completion rate (% of total enrollments) of Seychelles in 2000 to that in 2005?
Your response must be concise. 0.83. What is the ratio of the Primary completion rate (% of total enrollments) in Swaziland in 2000 to that in 2005?
Your response must be concise. 0.94. What is the ratio of the Primary completion rate (% of total enrollments) of Korea (Republic) in 2001 to that in 2002?
Provide a short and direct response. 1.05. What is the ratio of the Primary completion rate (% of total enrollments) of Mongolia in 2001 to that in 2002?
Make the answer very short. 0.92. What is the ratio of the Primary completion rate (% of total enrollments) of Seychelles in 2001 to that in 2002?
Make the answer very short. 1. What is the ratio of the Primary completion rate (% of total enrollments) in Swaziland in 2001 to that in 2002?
Your response must be concise. 0.97. What is the ratio of the Primary completion rate (% of total enrollments) in Mongolia in 2001 to that in 2003?
Keep it short and to the point. 0.9. What is the ratio of the Primary completion rate (% of total enrollments) of Seychelles in 2001 to that in 2003?
Ensure brevity in your answer.  0.98. What is the ratio of the Primary completion rate (% of total enrollments) of Swaziland in 2001 to that in 2003?
Your response must be concise. 1.01. What is the ratio of the Primary completion rate (% of total enrollments) of Mongolia in 2001 to that in 2004?
Your response must be concise. 0.92. What is the ratio of the Primary completion rate (% of total enrollments) of Seychelles in 2001 to that in 2004?
Offer a very short reply. 1. What is the ratio of the Primary completion rate (% of total enrollments) in Swaziland in 2001 to that in 2004?
Ensure brevity in your answer.  0.96. What is the ratio of the Primary completion rate (% of total enrollments) of Mongolia in 2001 to that in 2005?
Your answer should be very brief. 0.95. What is the ratio of the Primary completion rate (% of total enrollments) in Seychelles in 2001 to that in 2005?
Your response must be concise. 0.89. What is the ratio of the Primary completion rate (% of total enrollments) in Swaziland in 2001 to that in 2005?
Give a very brief answer. 0.91. What is the ratio of the Primary completion rate (% of total enrollments) of Korea (Republic) in 2002 to that in 2003?
Keep it short and to the point. 0.94. What is the ratio of the Primary completion rate (% of total enrollments) in Mongolia in 2002 to that in 2003?
Offer a very short reply. 0.98. What is the ratio of the Primary completion rate (% of total enrollments) in Seychelles in 2002 to that in 2003?
Ensure brevity in your answer.  0.98. What is the ratio of the Primary completion rate (% of total enrollments) in Swaziland in 2002 to that in 2003?
Provide a short and direct response. 1.05. What is the ratio of the Primary completion rate (% of total enrollments) in Korea (Republic) in 2002 to that in 2004?
Make the answer very short. 0.94. What is the ratio of the Primary completion rate (% of total enrollments) of Seychelles in 2002 to that in 2004?
Offer a terse response. 1. What is the ratio of the Primary completion rate (% of total enrollments) in Korea (Republic) in 2002 to that in 2005?
Keep it short and to the point. 0.95. What is the ratio of the Primary completion rate (% of total enrollments) in Mongolia in 2002 to that in 2005?
Give a very brief answer. 1.03. What is the ratio of the Primary completion rate (% of total enrollments) in Seychelles in 2002 to that in 2005?
Your response must be concise. 0.89. What is the ratio of the Primary completion rate (% of total enrollments) in Swaziland in 2002 to that in 2005?
Give a very brief answer. 0.94. What is the ratio of the Primary completion rate (% of total enrollments) of Mongolia in 2003 to that in 2004?
Your answer should be very brief. 1.01. What is the ratio of the Primary completion rate (% of total enrollments) in Seychelles in 2003 to that in 2004?
Offer a very short reply. 1.02. What is the ratio of the Primary completion rate (% of total enrollments) in Swaziland in 2003 to that in 2004?
Offer a terse response. 0.94. What is the ratio of the Primary completion rate (% of total enrollments) in Korea (Republic) in 2003 to that in 2005?
Your answer should be compact. 1.01. What is the ratio of the Primary completion rate (% of total enrollments) of Mongolia in 2003 to that in 2005?
Provide a succinct answer. 1.05. What is the ratio of the Primary completion rate (% of total enrollments) in Seychelles in 2003 to that in 2005?
Give a very brief answer. 0.91. What is the ratio of the Primary completion rate (% of total enrollments) of Swaziland in 2003 to that in 2005?
Your answer should be compact. 0.9. What is the ratio of the Primary completion rate (% of total enrollments) in Mongolia in 2004 to that in 2005?
Offer a terse response. 1.03. What is the ratio of the Primary completion rate (% of total enrollments) of Seychelles in 2004 to that in 2005?
Offer a very short reply. 0.89. What is the ratio of the Primary completion rate (% of total enrollments) in Swaziland in 2004 to that in 2005?
Your answer should be compact. 0.95. What is the difference between the highest and the second highest Primary completion rate (% of total enrollments) in Korea (Republic)?
Offer a very short reply. 0.3. What is the difference between the highest and the second highest Primary completion rate (% of total enrollments) in Mongolia?
Your response must be concise. 1.39. What is the difference between the highest and the second highest Primary completion rate (% of total enrollments) of Seychelles?
Offer a very short reply. 10.82. What is the difference between the highest and the second highest Primary completion rate (% of total enrollments) of Swaziland?
Give a very brief answer. 2.84. What is the difference between the highest and the lowest Primary completion rate (% of total enrollments) in Korea (Republic)?
Provide a short and direct response. 7.91. What is the difference between the highest and the lowest Primary completion rate (% of total enrollments) of Mongolia?
Make the answer very short. 14.78. What is the difference between the highest and the lowest Primary completion rate (% of total enrollments) of Seychelles?
Ensure brevity in your answer.  20.51. What is the difference between the highest and the lowest Primary completion rate (% of total enrollments) in Swaziland?
Provide a succinct answer. 6.29. 